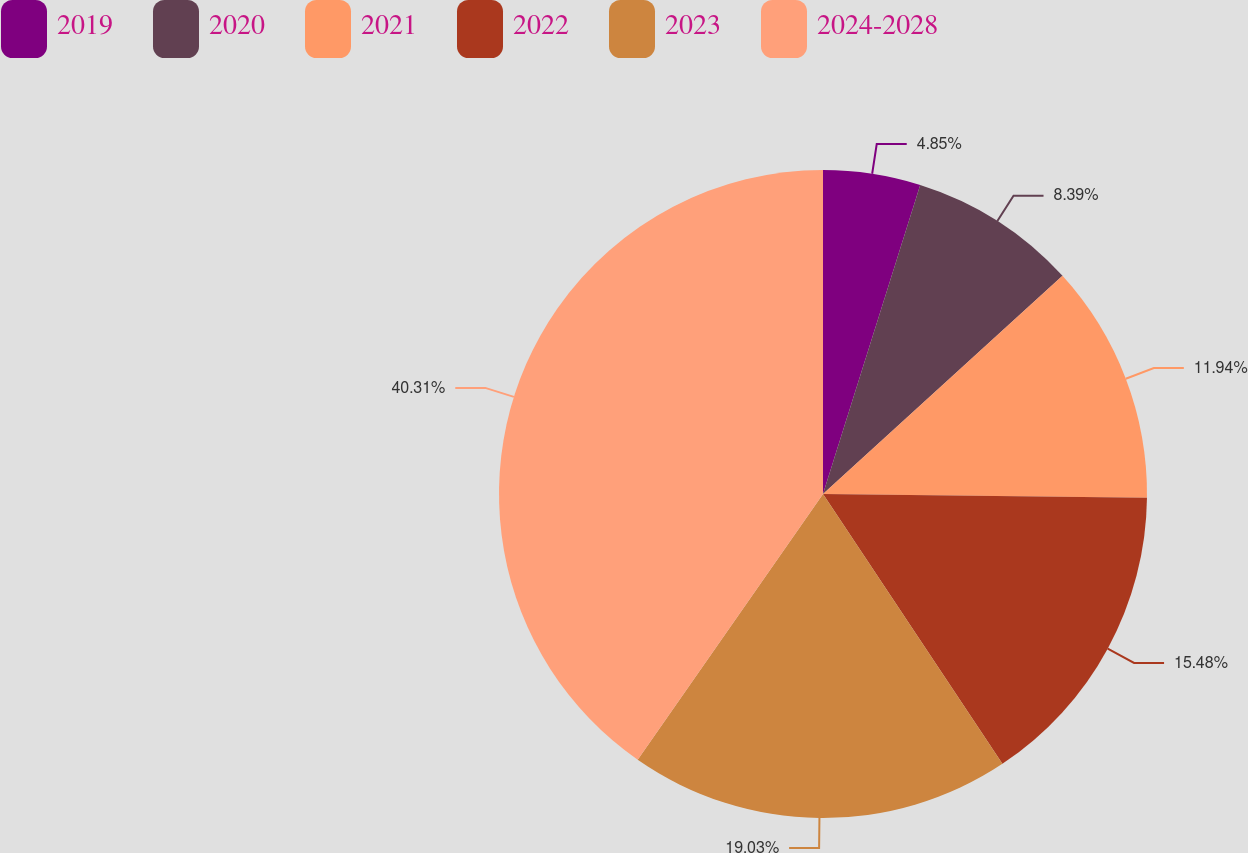<chart> <loc_0><loc_0><loc_500><loc_500><pie_chart><fcel>2019<fcel>2020<fcel>2021<fcel>2022<fcel>2023<fcel>2024-2028<nl><fcel>4.85%<fcel>8.39%<fcel>11.94%<fcel>15.48%<fcel>19.03%<fcel>40.31%<nl></chart> 